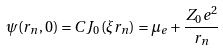Convert formula to latex. <formula><loc_0><loc_0><loc_500><loc_500>\psi ( r _ { n } , 0 ) = C J _ { 0 } ( \xi r _ { n } ) = \mu _ { e } + \frac { Z _ { 0 } e ^ { 2 } } { r _ { n } }</formula> 